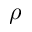Convert formula to latex. <formula><loc_0><loc_0><loc_500><loc_500>\rho</formula> 